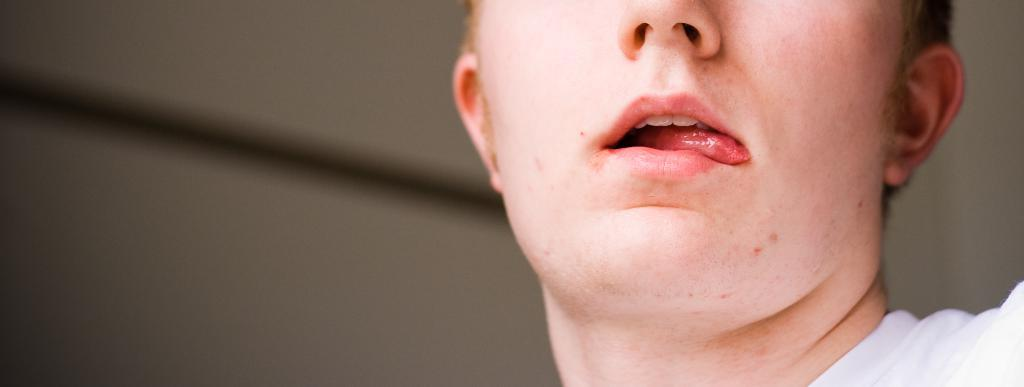What is the main subject of the image? There is a person in the image. Can you describe the setting or environment in the image? There is a background in the image. How many frogs are sitting on the tray in the image? There is no tray or frogs present in the image. 